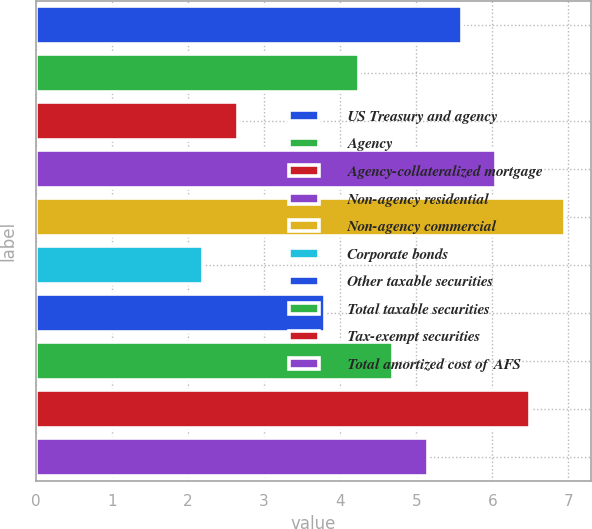<chart> <loc_0><loc_0><loc_500><loc_500><bar_chart><fcel>US Treasury and agency<fcel>Agency<fcel>Agency-collateralized mortgage<fcel>Non-agency residential<fcel>Non-agency commercial<fcel>Corporate bonds<fcel>Other taxable securities<fcel>Total taxable securities<fcel>Tax-exempt securities<fcel>Total amortized cost of AFS<nl><fcel>5.6<fcel>4.25<fcel>2.65<fcel>6.05<fcel>6.95<fcel>2.2<fcel>3.8<fcel>4.7<fcel>6.5<fcel>5.15<nl></chart> 